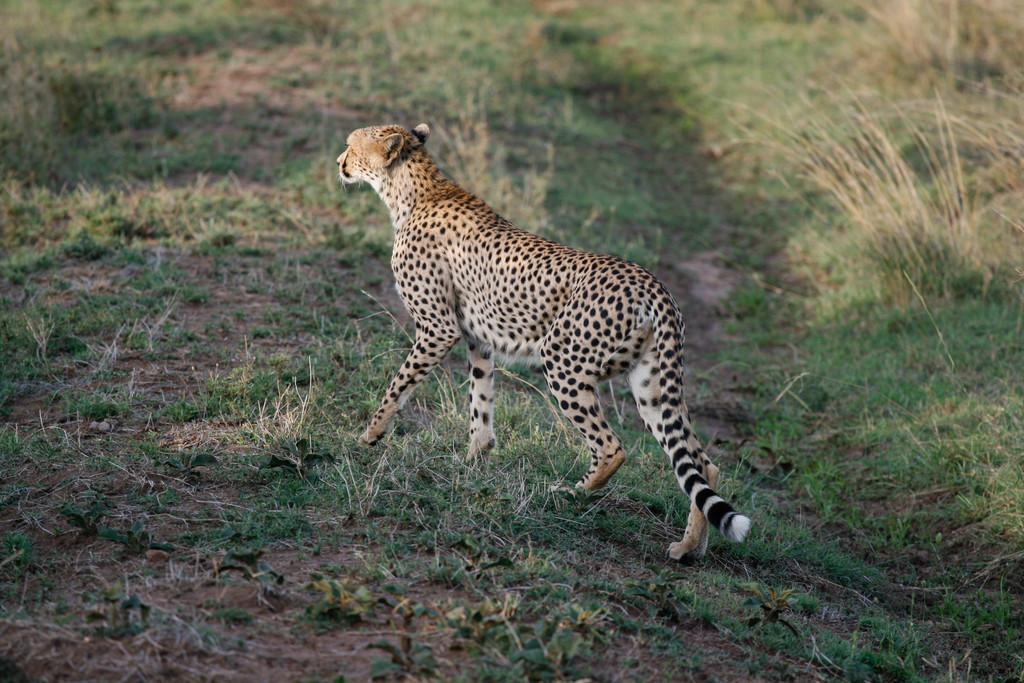In one or two sentences, can you explain what this image depicts? In this image there is a cheetah standing, and in the background there is grass. 